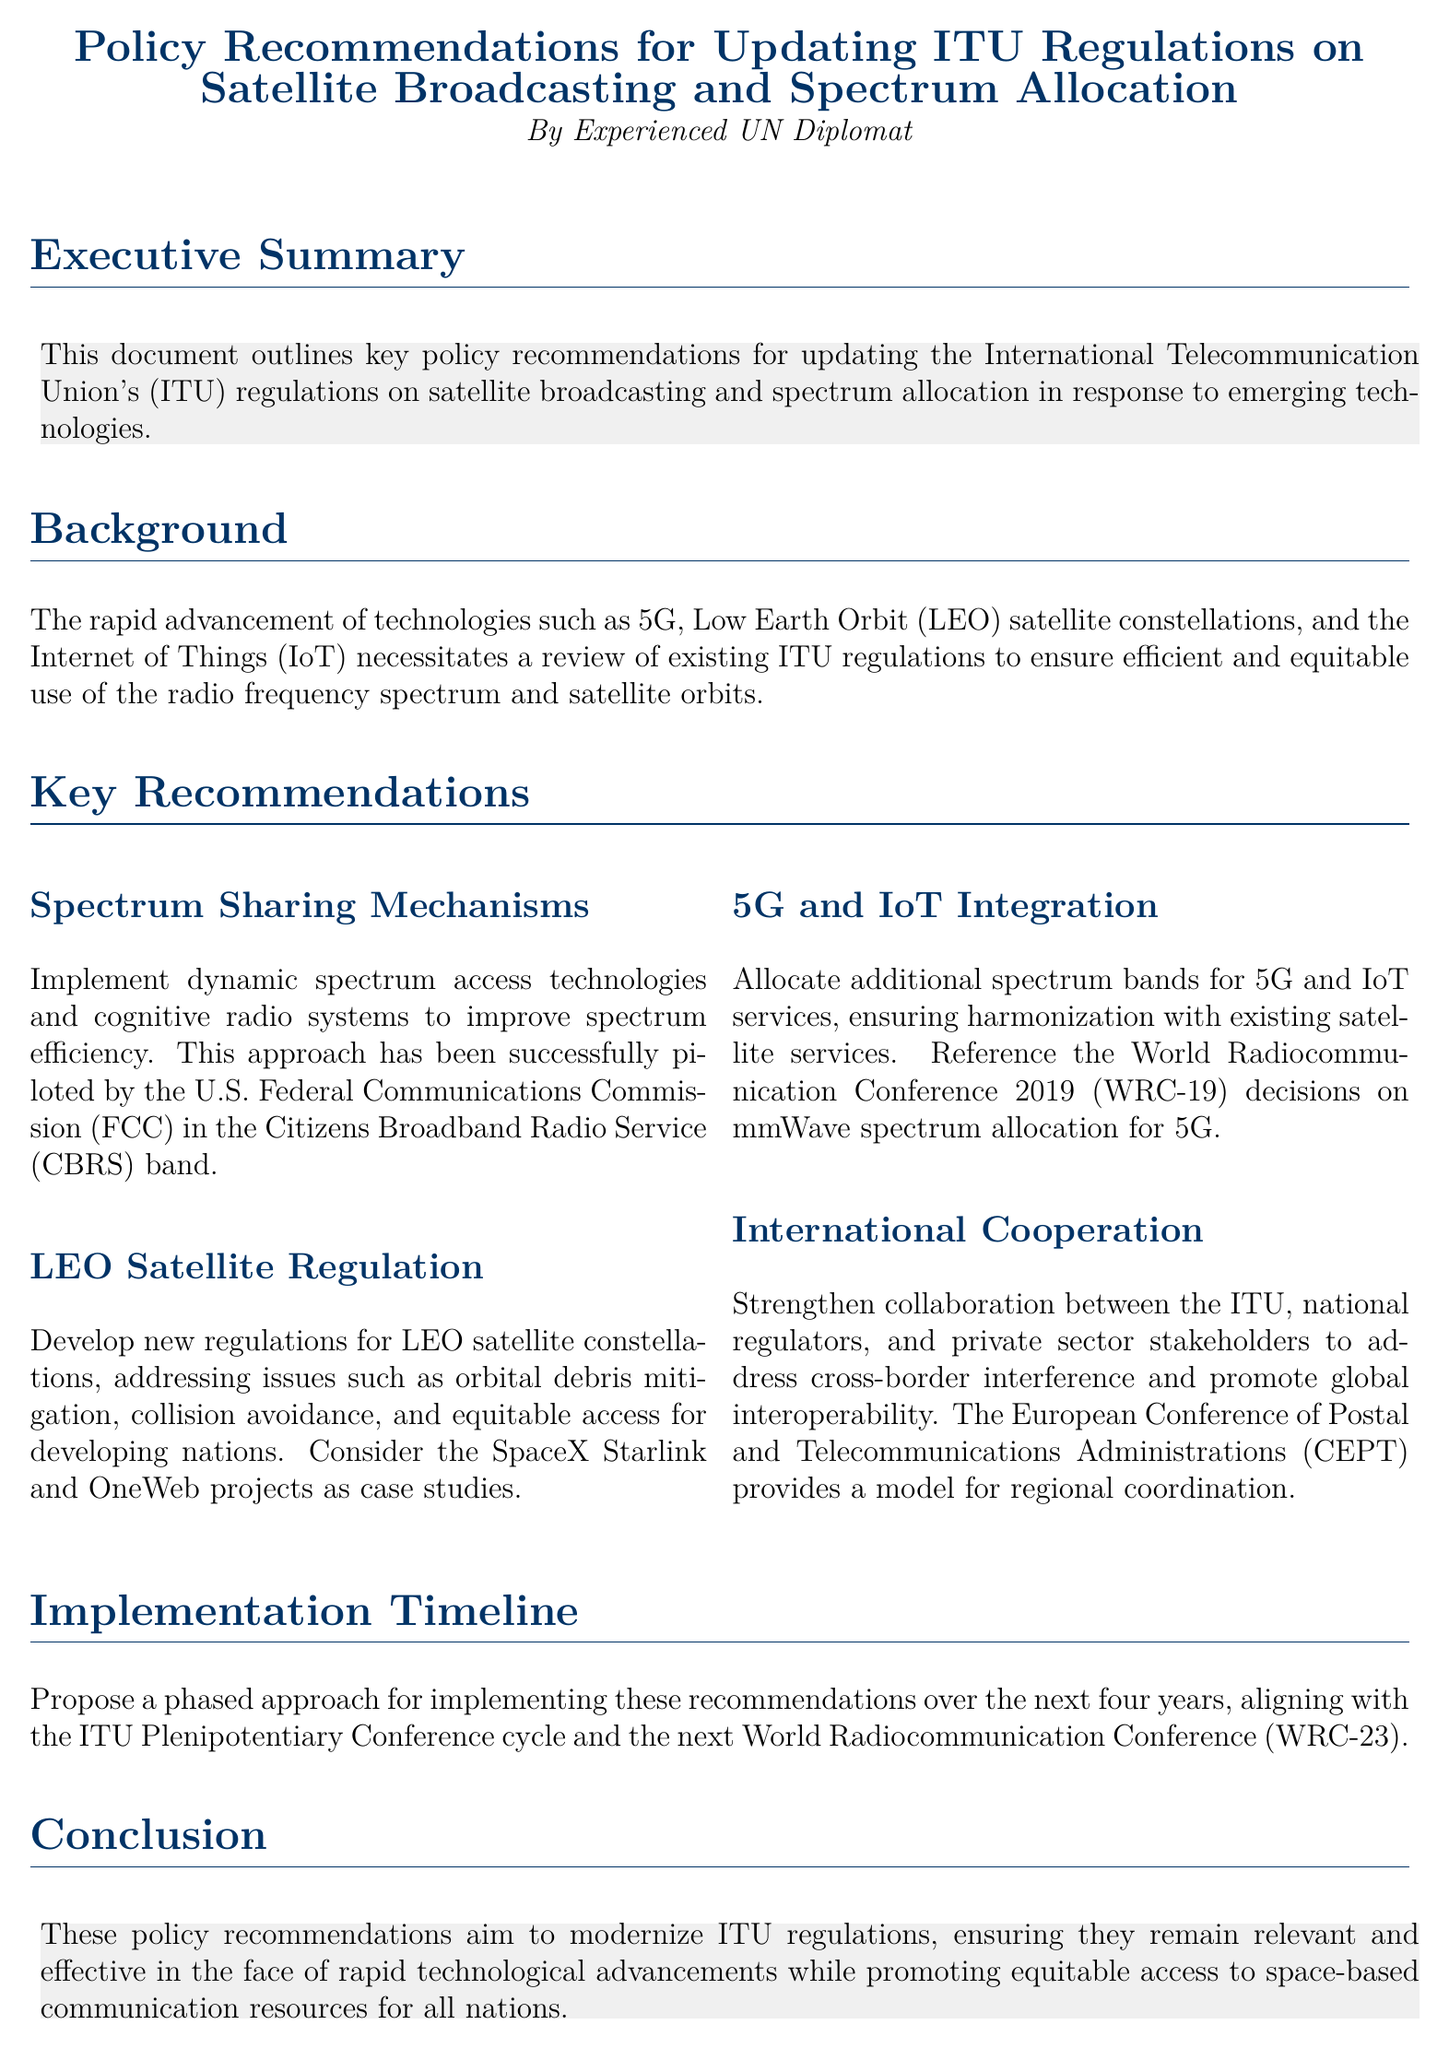What is the title of the document? The title is explicitly stated at the beginning of the document.
Answer: Policy Recommendations for Updating ITU Regulations on Satellite Broadcasting and Spectrum Allocation Who authored the document? The author is specified in the header section of the document.
Answer: Experienced UN Diplomat What term is used to refer to the new technologies discussed in the document? The document specifically mentions "emerging technologies" in the executive summary.
Answer: Emerging technologies How many key recommendations are presented in the document? The document provides four key recommendations.
Answer: Four What is one of the key recommendations related to satellite constellations? The document explicitly mentions regulations for LEO satellite constellations as a key recommendation.
Answer: LEO Satellite Regulation What is the implementation timeline proposed in the document? The document suggests a phased approach aligning with specific ITU conference cycles.
Answer: Four years What mechanism is proposed for improving spectrum efficiency? The document refers to "dynamic spectrum access technologies" as a suggested mechanism.
Answer: Dynamic spectrum access technologies Which event's decisions are referenced for spectrum allocation? The document states that the decisions from WRC-19 are referenced for 5G spectrum allocation.
Answer: WRC-19 